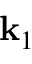<formula> <loc_0><loc_0><loc_500><loc_500>k _ { 1 }</formula> 